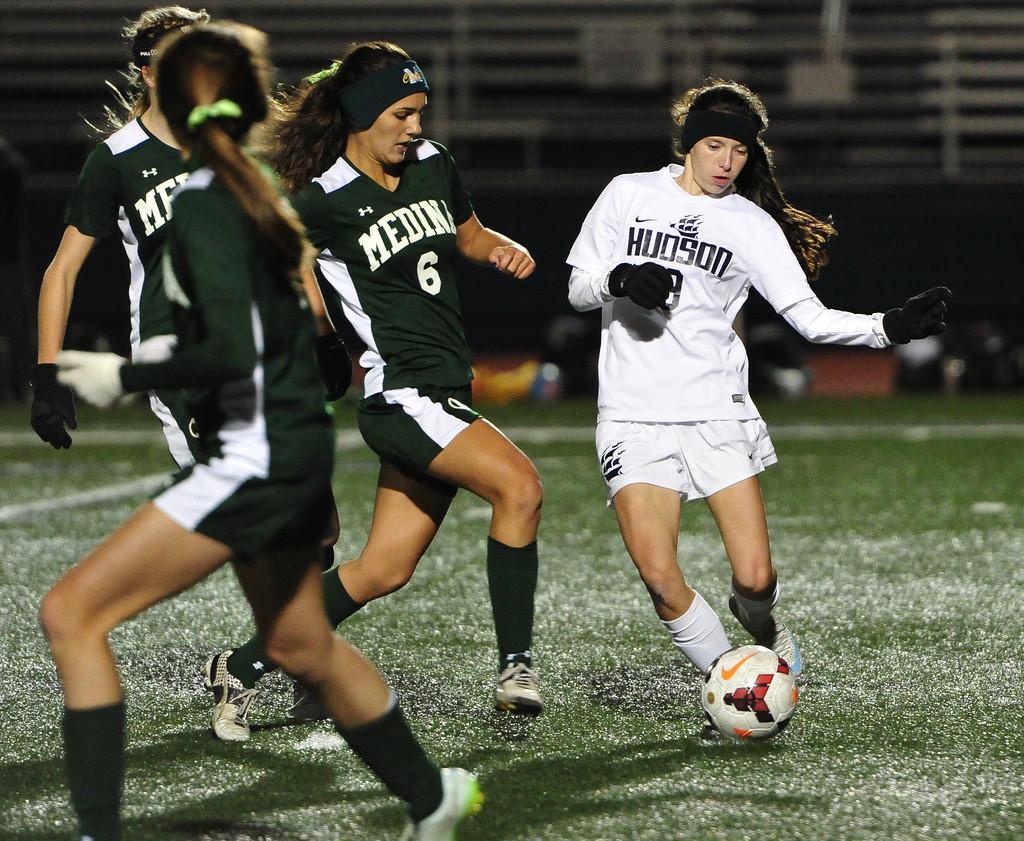Please provide a concise description of this image. Here we can see four persons are playing football. And this is grass. 